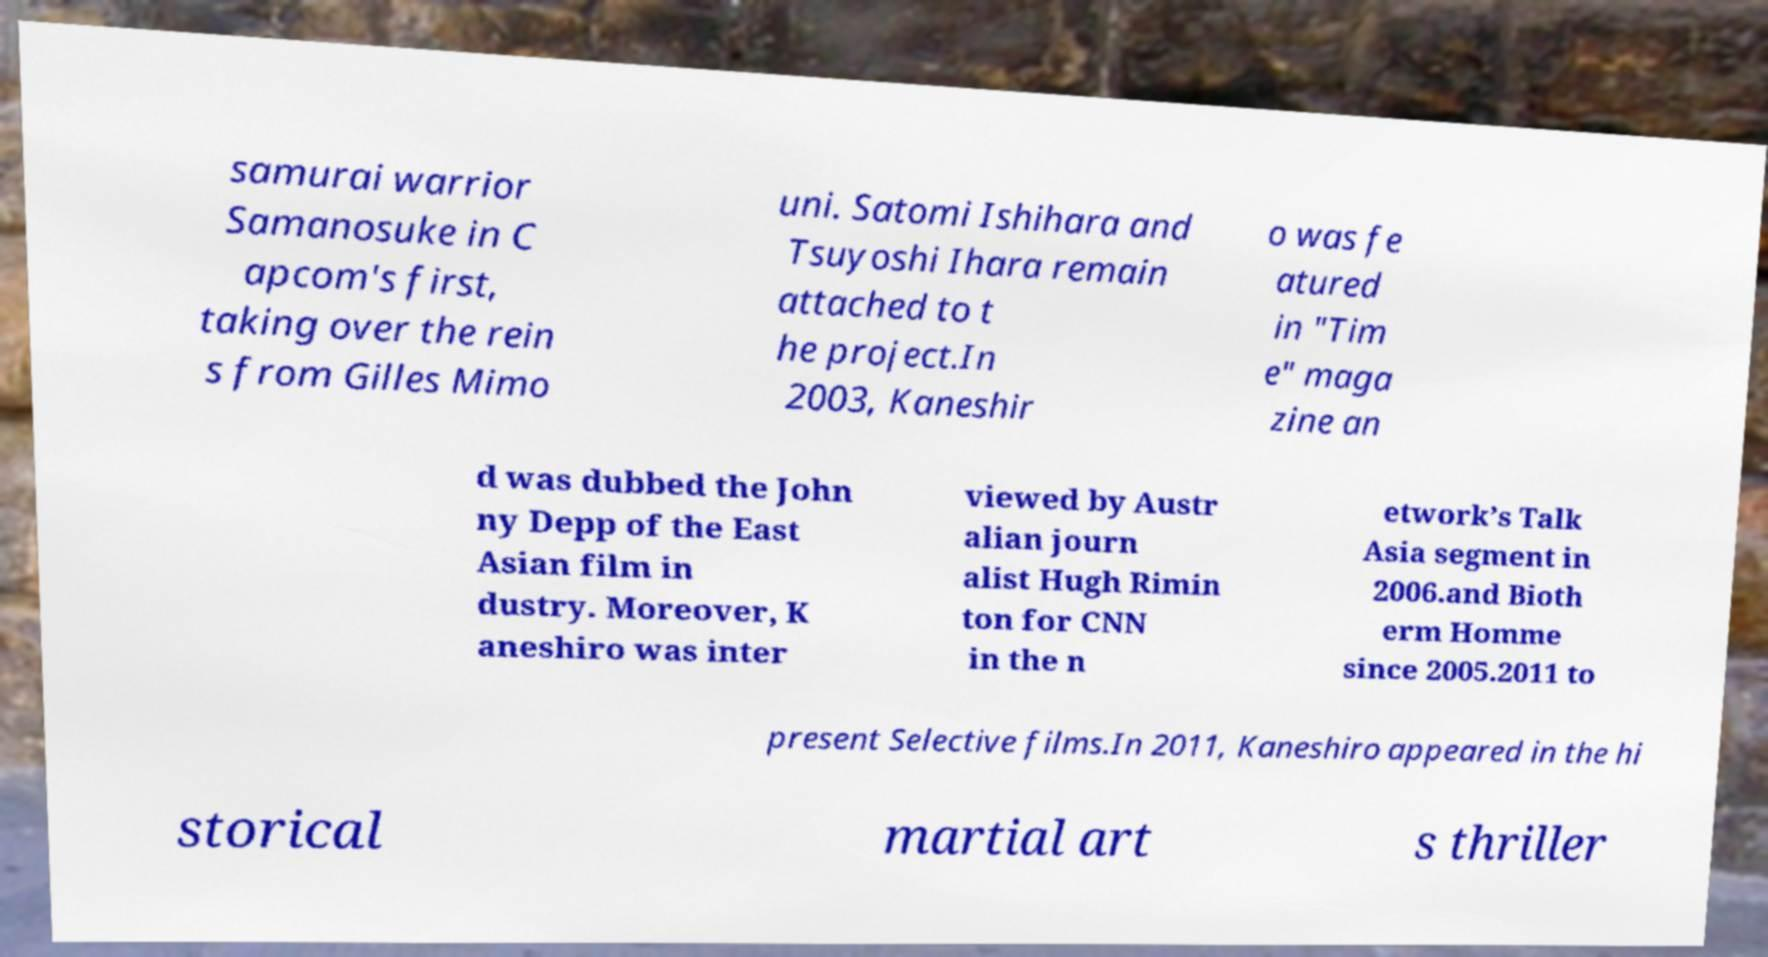Could you assist in decoding the text presented in this image and type it out clearly? samurai warrior Samanosuke in C apcom's first, taking over the rein s from Gilles Mimo uni. Satomi Ishihara and Tsuyoshi Ihara remain attached to t he project.In 2003, Kaneshir o was fe atured in "Tim e" maga zine an d was dubbed the John ny Depp of the East Asian film in dustry. Moreover, K aneshiro was inter viewed by Austr alian journ alist Hugh Rimin ton for CNN in the n etwork’s Talk Asia segment in 2006.and Bioth erm Homme since 2005.2011 to present Selective films.In 2011, Kaneshiro appeared in the hi storical martial art s thriller 